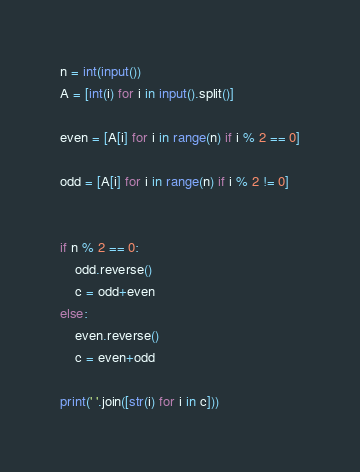Convert code to text. <code><loc_0><loc_0><loc_500><loc_500><_Python_>n = int(input())
A = [int(i) for i in input().split()]

even = [A[i] for i in range(n) if i % 2 == 0]

odd = [A[i] for i in range(n) if i % 2 != 0]


if n % 2 == 0:
    odd.reverse()
    c = odd+even
else:
    even.reverse()
    c = even+odd
    
print(' '.join([str(i) for i in c]))</code> 